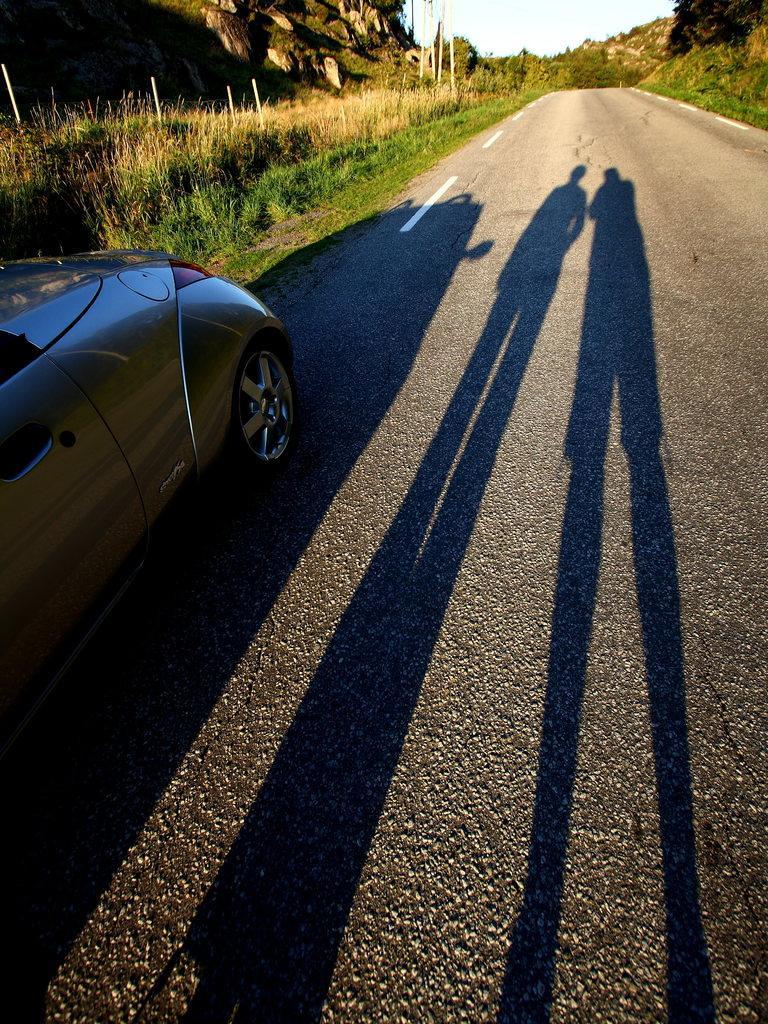In one or two sentences, can you explain what this image depicts? In this image there is a car on a road and there is a shadow of two persons, on either side of the road there are plants, in the background there is a are mountains and the sky. 